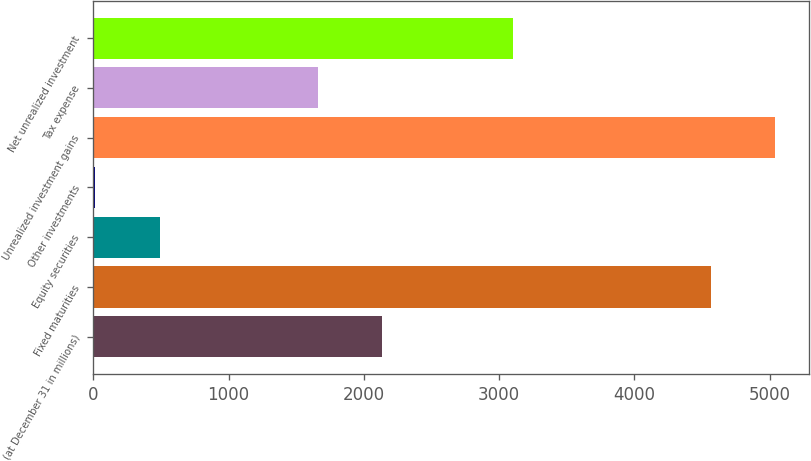Convert chart to OTSL. <chart><loc_0><loc_0><loc_500><loc_500><bar_chart><fcel>(at December 31 in millions)<fcel>Fixed maturities<fcel>Equity securities<fcel>Other investments<fcel>Unrealized investment gains<fcel>Tax expense<fcel>Net unrealized investment<nl><fcel>2132.7<fcel>4564<fcel>488.7<fcel>14<fcel>5038.7<fcel>1658<fcel>3103<nl></chart> 